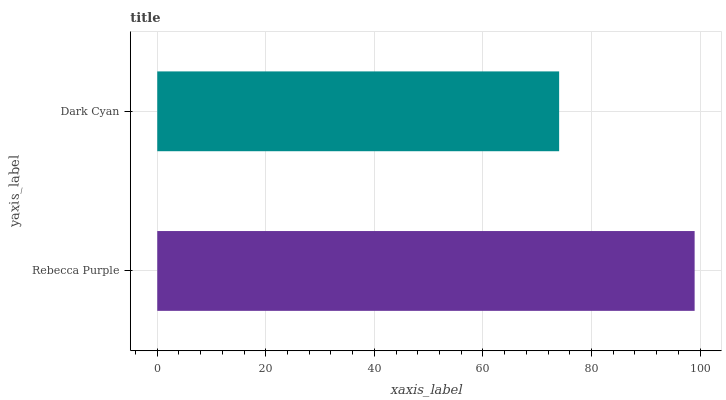Is Dark Cyan the minimum?
Answer yes or no. Yes. Is Rebecca Purple the maximum?
Answer yes or no. Yes. Is Dark Cyan the maximum?
Answer yes or no. No. Is Rebecca Purple greater than Dark Cyan?
Answer yes or no. Yes. Is Dark Cyan less than Rebecca Purple?
Answer yes or no. Yes. Is Dark Cyan greater than Rebecca Purple?
Answer yes or no. No. Is Rebecca Purple less than Dark Cyan?
Answer yes or no. No. Is Rebecca Purple the high median?
Answer yes or no. Yes. Is Dark Cyan the low median?
Answer yes or no. Yes. Is Dark Cyan the high median?
Answer yes or no. No. Is Rebecca Purple the low median?
Answer yes or no. No. 